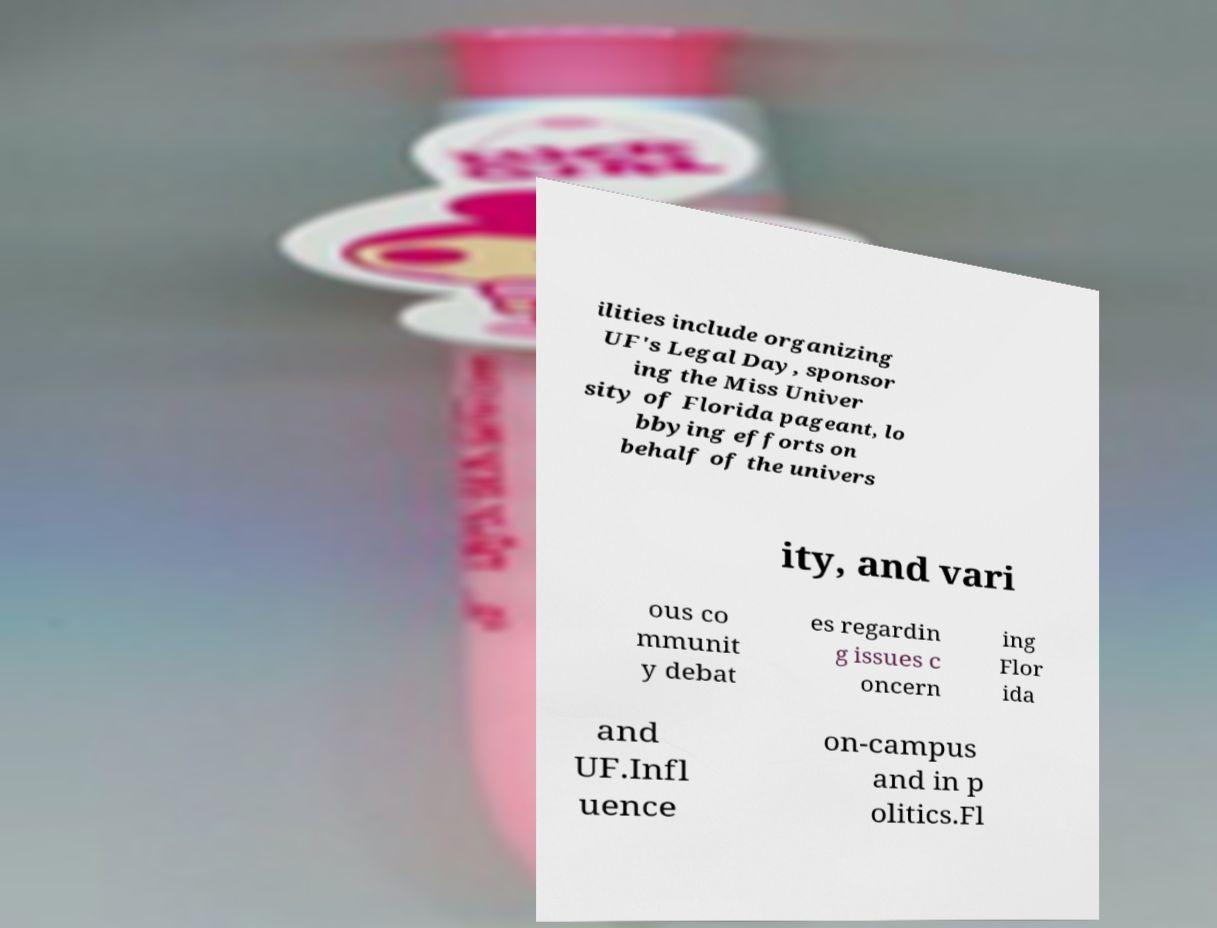I need the written content from this picture converted into text. Can you do that? ilities include organizing UF's Legal Day, sponsor ing the Miss Univer sity of Florida pageant, lo bbying efforts on behalf of the univers ity, and vari ous co mmunit y debat es regardin g issues c oncern ing Flor ida and UF.Infl uence on-campus and in p olitics.Fl 